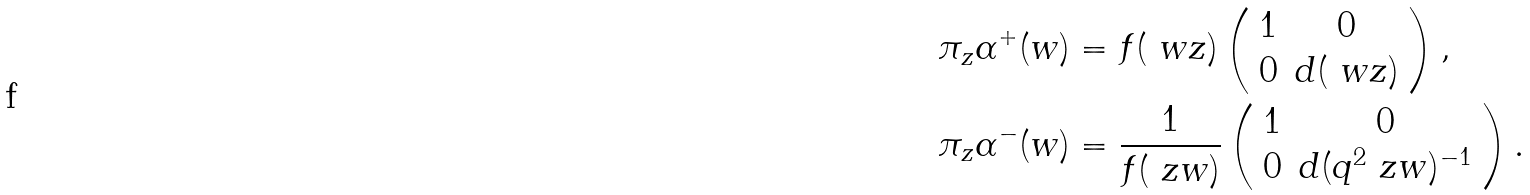Convert formula to latex. <formula><loc_0><loc_0><loc_500><loc_500>\pi _ { z } \alpha ^ { + } ( w ) & = f ( \ w z ) \left ( \begin{array} { c c } 1 & 0 \\ 0 & d ( \ w z ) \end{array} \right ) , \\ \pi _ { z } \alpha ^ { - } ( w ) & = \frac { 1 } { f ( \ z w ) } \left ( \begin{array} { c c } 1 & 0 \\ 0 & d ( q ^ { 2 } \ z w ) ^ { - 1 } \end{array} \right ) .</formula> 